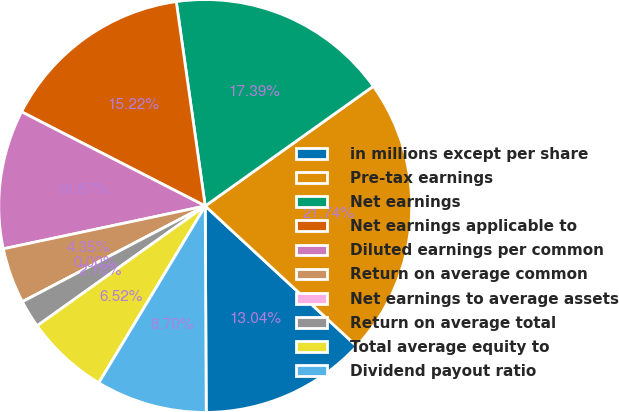<chart> <loc_0><loc_0><loc_500><loc_500><pie_chart><fcel>in millions except per share<fcel>Pre-tax earnings<fcel>Net earnings<fcel>Net earnings applicable to<fcel>Diluted earnings per common<fcel>Return on average common<fcel>Net earnings to average assets<fcel>Return on average total<fcel>Total average equity to<fcel>Dividend payout ratio<nl><fcel>13.04%<fcel>21.74%<fcel>17.39%<fcel>15.22%<fcel>10.87%<fcel>4.35%<fcel>0.0%<fcel>2.18%<fcel>6.52%<fcel>8.7%<nl></chart> 